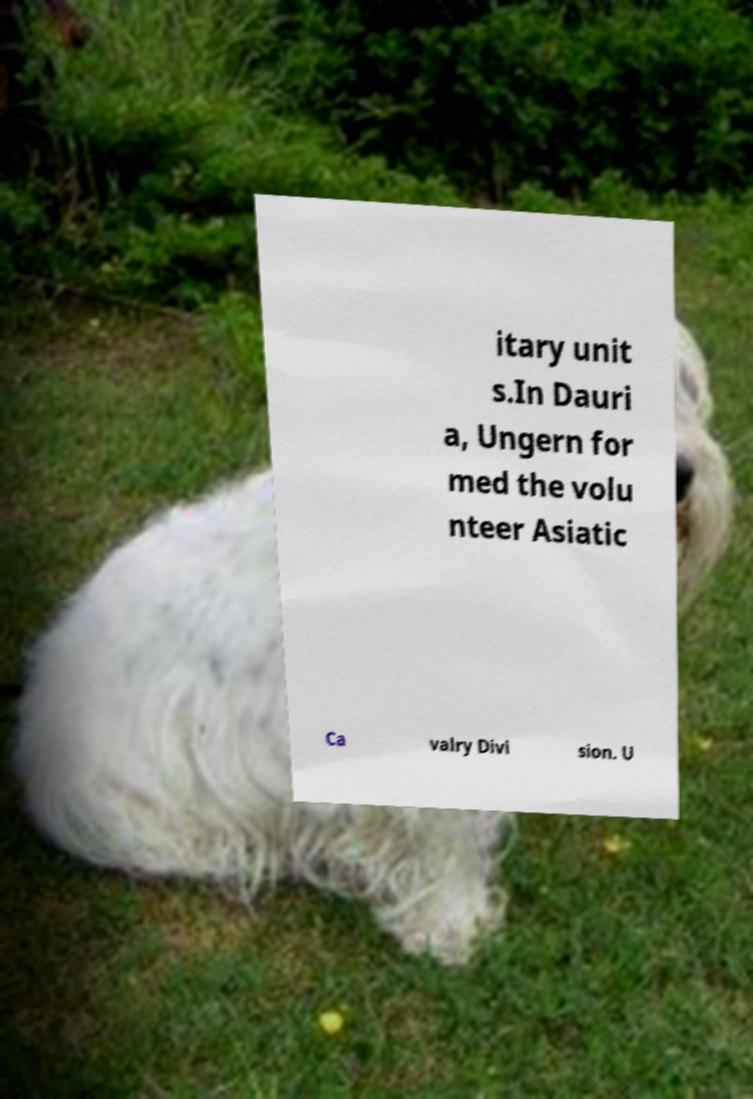Could you extract and type out the text from this image? itary unit s.In Dauri a, Ungern for med the volu nteer Asiatic Ca valry Divi sion. U 